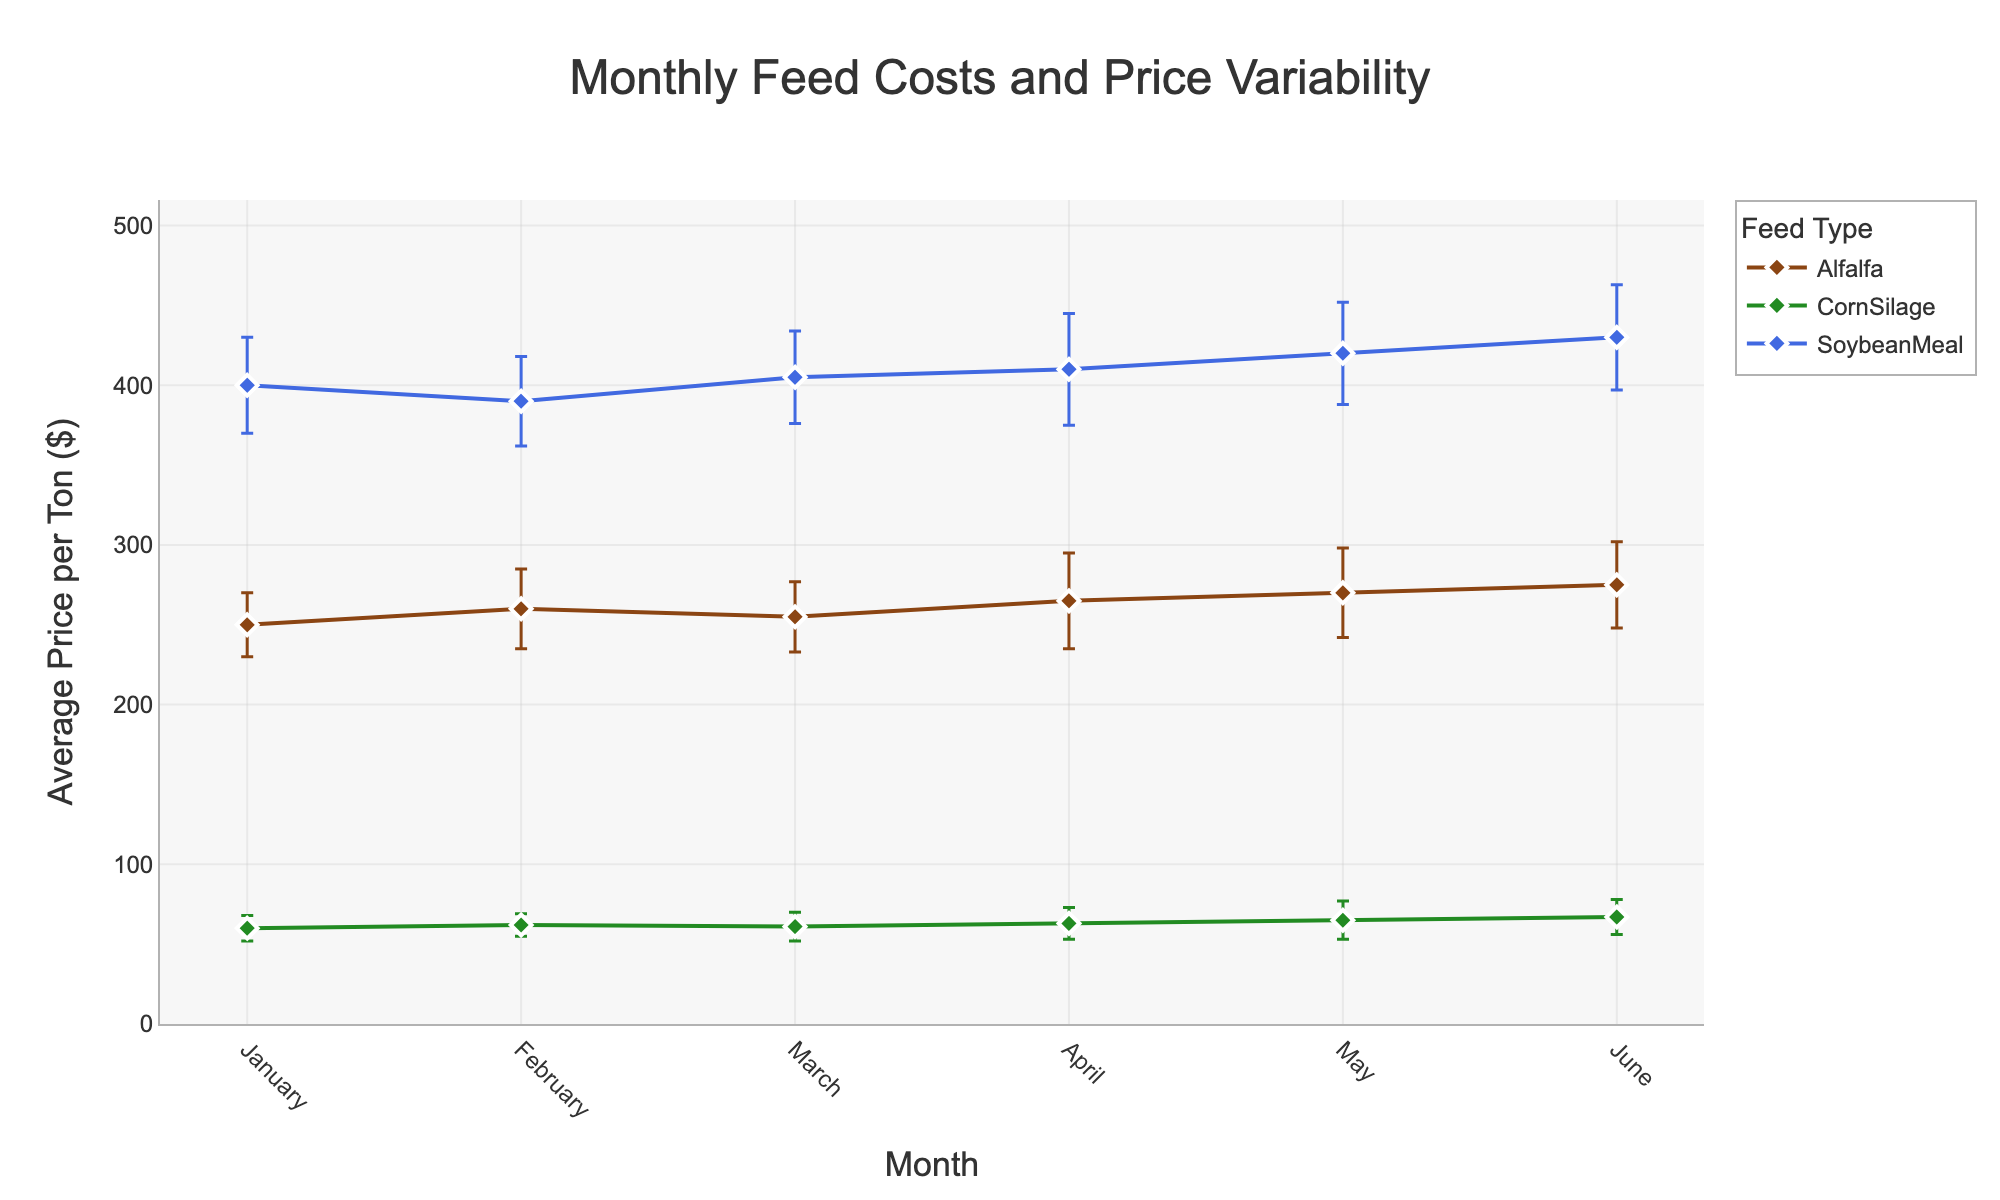What's the title of the figure? The title is located at the top of the figure and it describes the overall content of the plot.
Answer: Monthly Feed Costs and Price Variability What are the feed types included in the figure? The figure legend describes the categories or feed types represented in the plot. The feed types listed are Alfalfa, Corn Silage, and Soybean Meal.
Answer: Alfalfa, Corn Silage, Soybean Meal Which month has the highest average price for Soybean Meal? By looking at the blue line (representing Soybean Meal) and its markers in the figure, the highest point occurs in June.
Answer: June Which feed type has the highest price variability in April? The error bars indicate price variability. In April, the feed type with the largest error bar is Soybean Meal which has the longest error bar among the three feed types.
Answer: Soybean Meal How does the average price of Alfalfa change from January to June? To determine this, note the start and end points of the brown line (representing Alfalfa) from January to June. The average price increases from $250 to $275.
Answer: It increases from $250 to $275 What is the difference in the average price of Corn Silage between February and April? Note the values of the green line (representing Corn Silage) in February ($62) and April ($63). The difference is $63 - $62 = $1.
Answer: $1 Which month has the smallest price variability for Corn Silage? By examining the length of the error bars on the green line (representing Corn Silage) across different months, the shortest error bar is in February.
Answer: February Compare the average prices of all feed types in May. Which one is highest? Look at the markers in May for each of the three feeds. The highest point is the blue diamond, which represents Soybean Meal priced at $420.
Answer: Soybean Meal Which feed type shows the most steady price over the months? Compare the fluctuations of each line representing the feed types. The Corn Silage line (green) shows the least variation in its values, indicating steady prices.
Answer: Corn Silage 